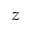<formula> <loc_0><loc_0><loc_500><loc_500>z</formula> 